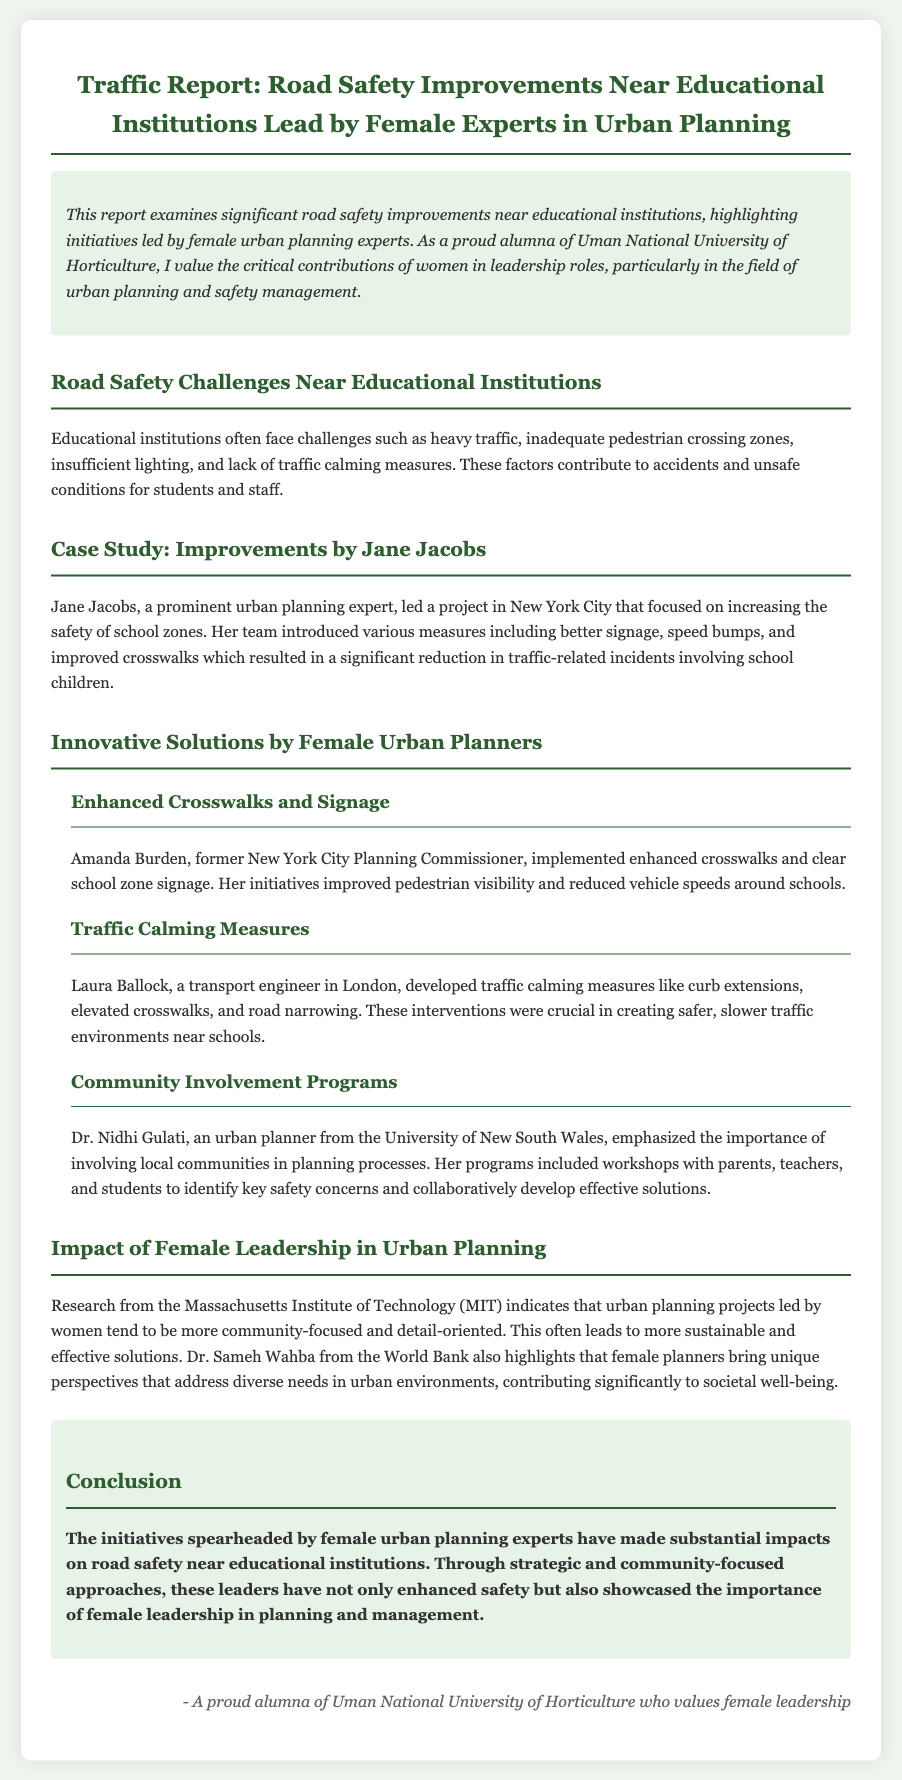What are the common challenges near educational institutions? The document lists challenges such as heavy traffic, inadequate pedestrian crossing zones, insufficient lighting, and lack of traffic calming measures.
Answer: Heavy traffic, inadequate pedestrian crossing zones, insufficient lighting, lack of traffic calming measures Who led the project in New York City for school zone safety? The document mentions Jane Jacobs as the prominent urban planning expert who led the project.
Answer: Jane Jacobs What improvements did Amanda Burden implement? The report states that Amanda Burden implemented enhanced crosswalks and clear school zone signage.
Answer: Enhanced crosswalks and clear school zone signage Which urban planner emphasized community involvement? The document specifies Dr. Nidhi Gulati as the urban planner who emphasized community involvement in planning processes.
Answer: Dr. Nidhi Gulati What does the research from MIT highlight about projects led by women? The report indicates that research from MIT suggests that urban planning projects led by women are more community-focused and detail-oriented.
Answer: More community-focused and detail-oriented What type of measures did Laura Ballock develop? According to the document, Laura Ballock developed traffic calming measures like curb extensions, elevated crosswalks, and road narrowing.
Answer: Traffic calming measures What is the conclusion of the report? The conclusion states that initiatives by female urban planning experts have significantly impacted road safety near educational institutions and highlighted the importance of female leadership.
Answer: Initiatives by female urban planning experts have significantly impacted road safety near educational institutions and highlighted the importance of female leadership 